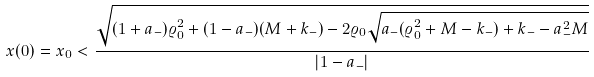Convert formula to latex. <formula><loc_0><loc_0><loc_500><loc_500>x ( 0 ) = x _ { 0 } < \frac { \sqrt { ( 1 + a _ { - } ) \varrho ^ { 2 } _ { 0 } + ( 1 - a _ { - } ) ( M + k _ { - } ) - 2 \varrho _ { 0 } \sqrt { a _ { - } ( \varrho ^ { 2 } _ { 0 } + M - k _ { - } ) + k _ { - } - a ^ { 2 } _ { - } M } } } { | 1 - a _ { - } | }</formula> 